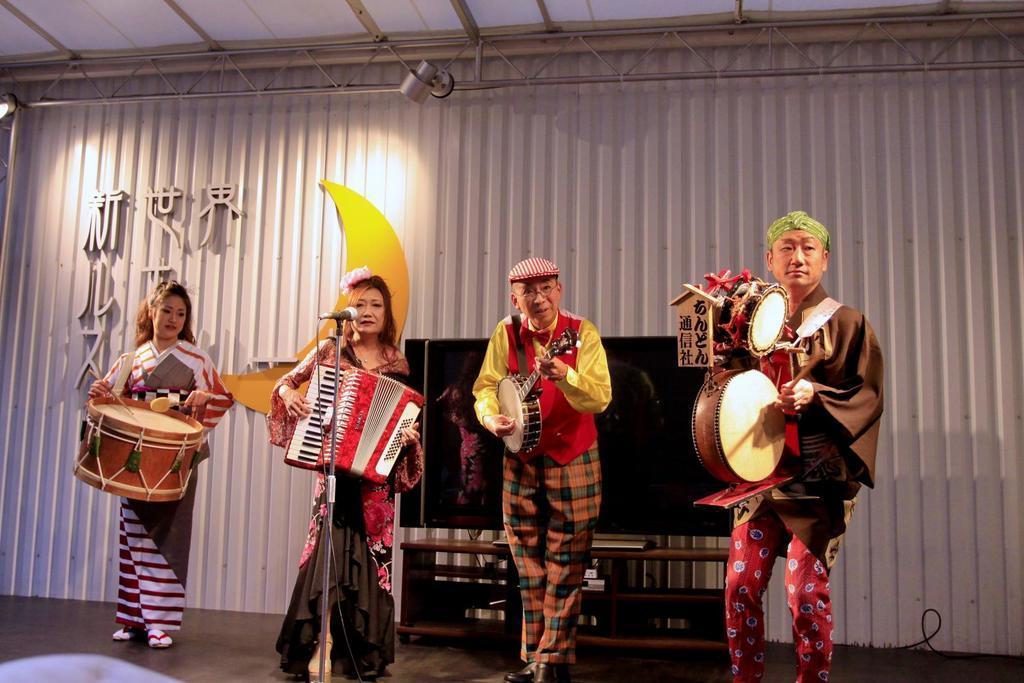How would you summarize this image in a sentence or two? In this picture we can see two woman and two men standing on stage and playing musical instrument such as drums, accordion and singing on mic and in background we can see wall, lights. 